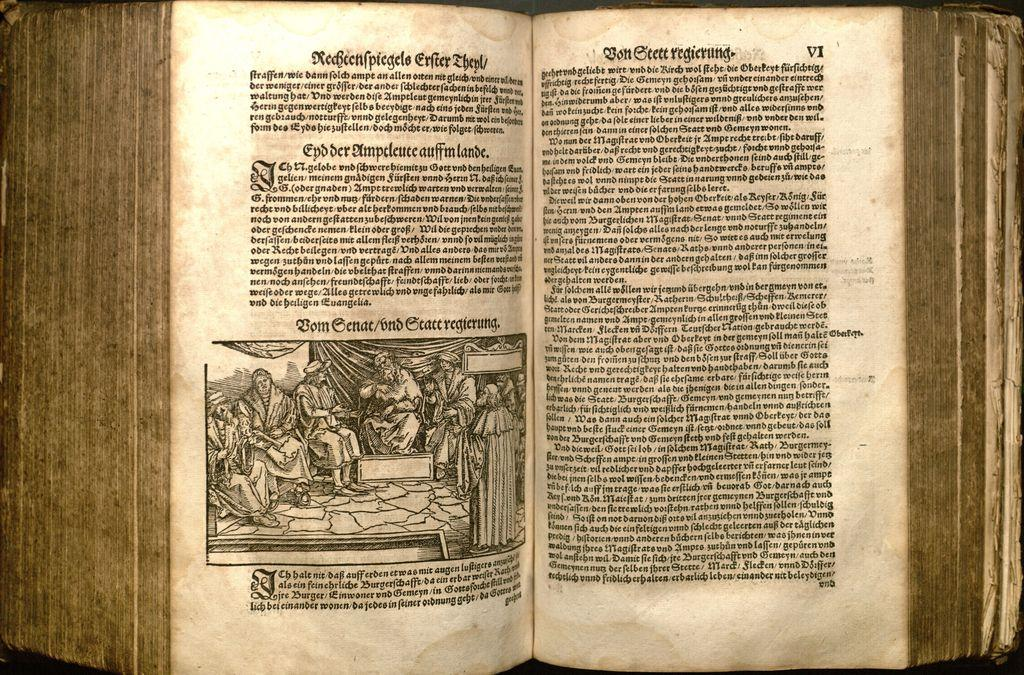<image>
Present a compact description of the photo's key features. An ancient book opened to a page with a drawing titled 'Bom Genat/andGtatt reierung'. 